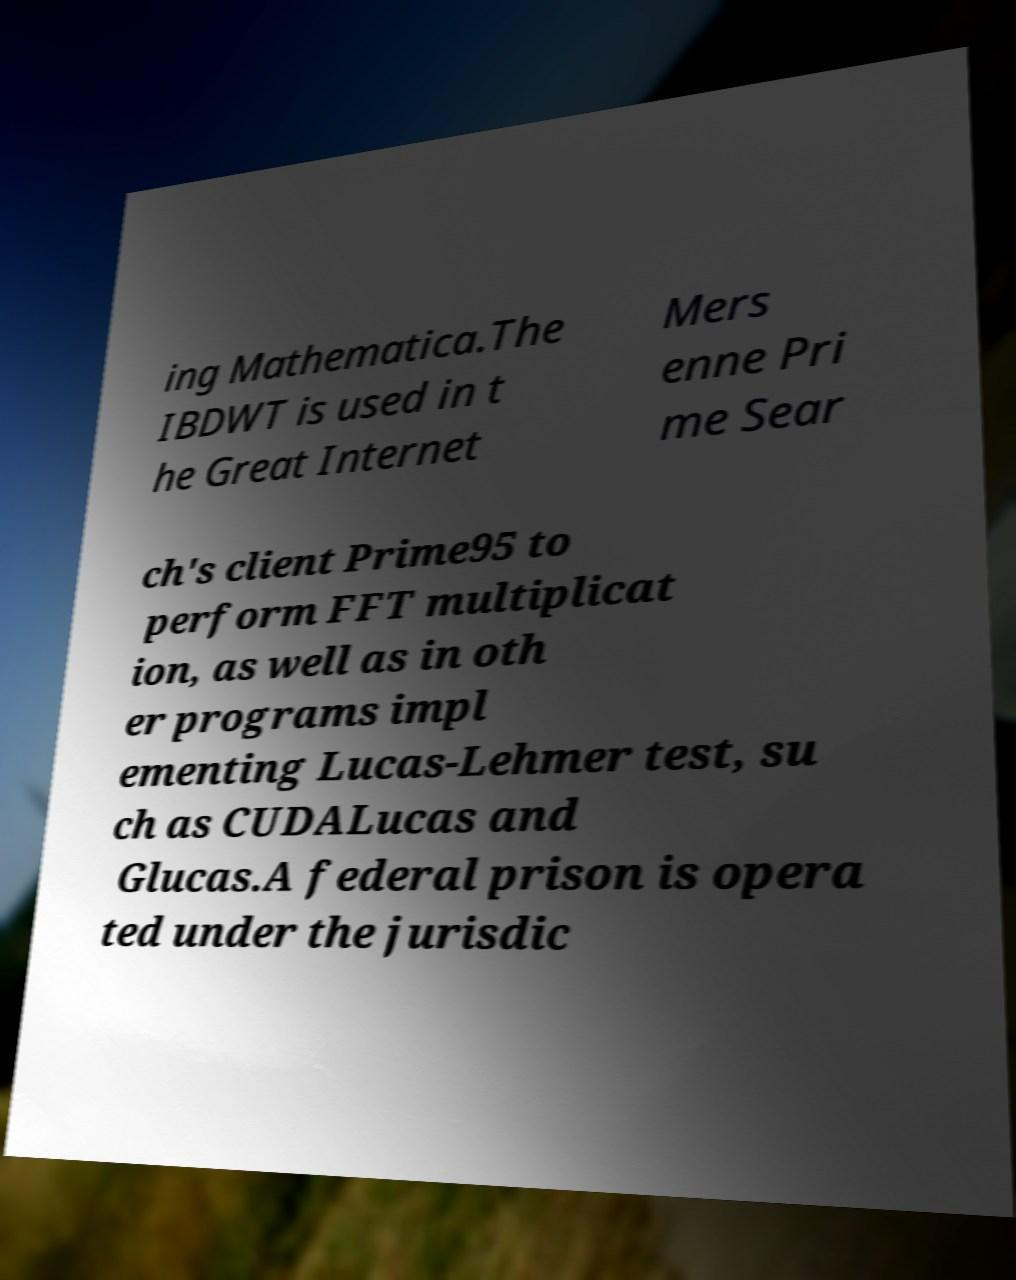Can you read and provide the text displayed in the image?This photo seems to have some interesting text. Can you extract and type it out for me? ing Mathematica.The IBDWT is used in t he Great Internet Mers enne Pri me Sear ch's client Prime95 to perform FFT multiplicat ion, as well as in oth er programs impl ementing Lucas-Lehmer test, su ch as CUDALucas and Glucas.A federal prison is opera ted under the jurisdic 